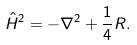Convert formula to latex. <formula><loc_0><loc_0><loc_500><loc_500>\hat { H } ^ { 2 } = - \nabla ^ { 2 } + \frac { 1 } { 4 } R .</formula> 